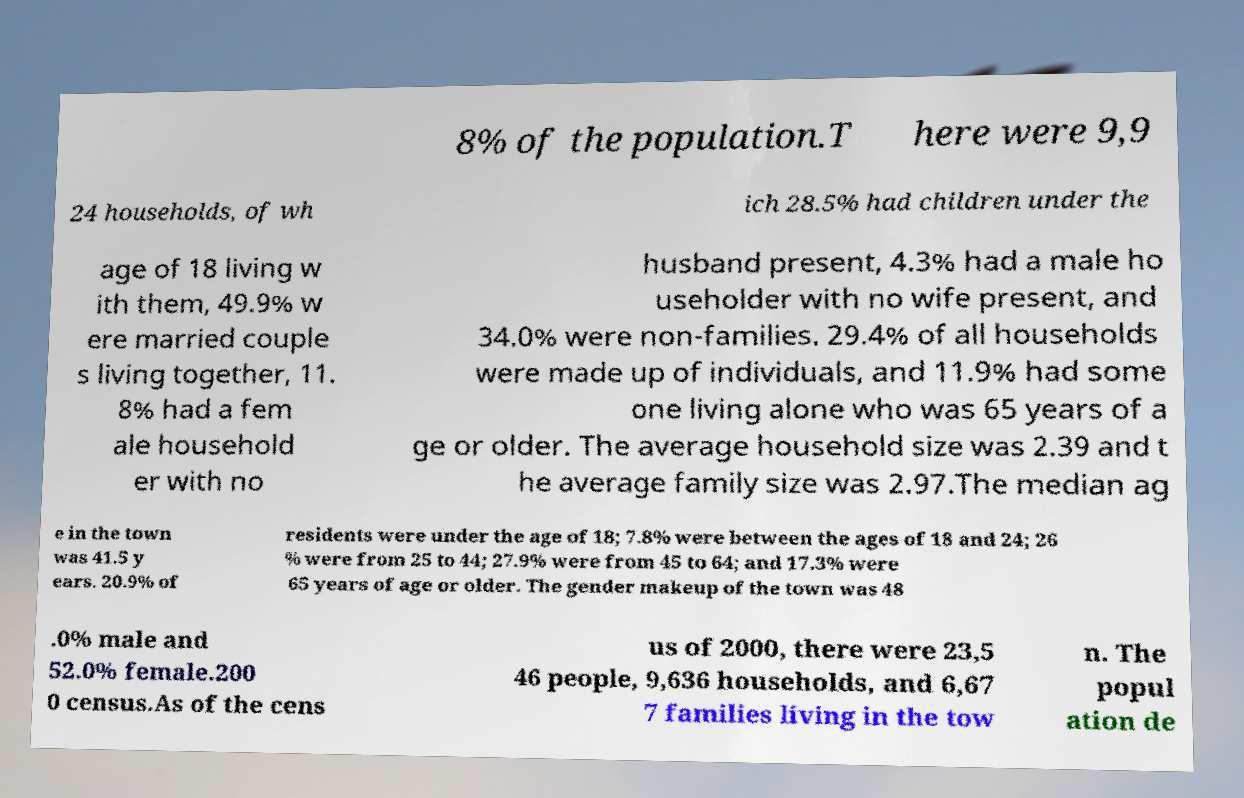Can you accurately transcribe the text from the provided image for me? 8% of the population.T here were 9,9 24 households, of wh ich 28.5% had children under the age of 18 living w ith them, 49.9% w ere married couple s living together, 11. 8% had a fem ale household er with no husband present, 4.3% had a male ho useholder with no wife present, and 34.0% were non-families. 29.4% of all households were made up of individuals, and 11.9% had some one living alone who was 65 years of a ge or older. The average household size was 2.39 and t he average family size was 2.97.The median ag e in the town was 41.5 y ears. 20.9% of residents were under the age of 18; 7.8% were between the ages of 18 and 24; 26 % were from 25 to 44; 27.9% were from 45 to 64; and 17.3% were 65 years of age or older. The gender makeup of the town was 48 .0% male and 52.0% female.200 0 census.As of the cens us of 2000, there were 23,5 46 people, 9,636 households, and 6,67 7 families living in the tow n. The popul ation de 